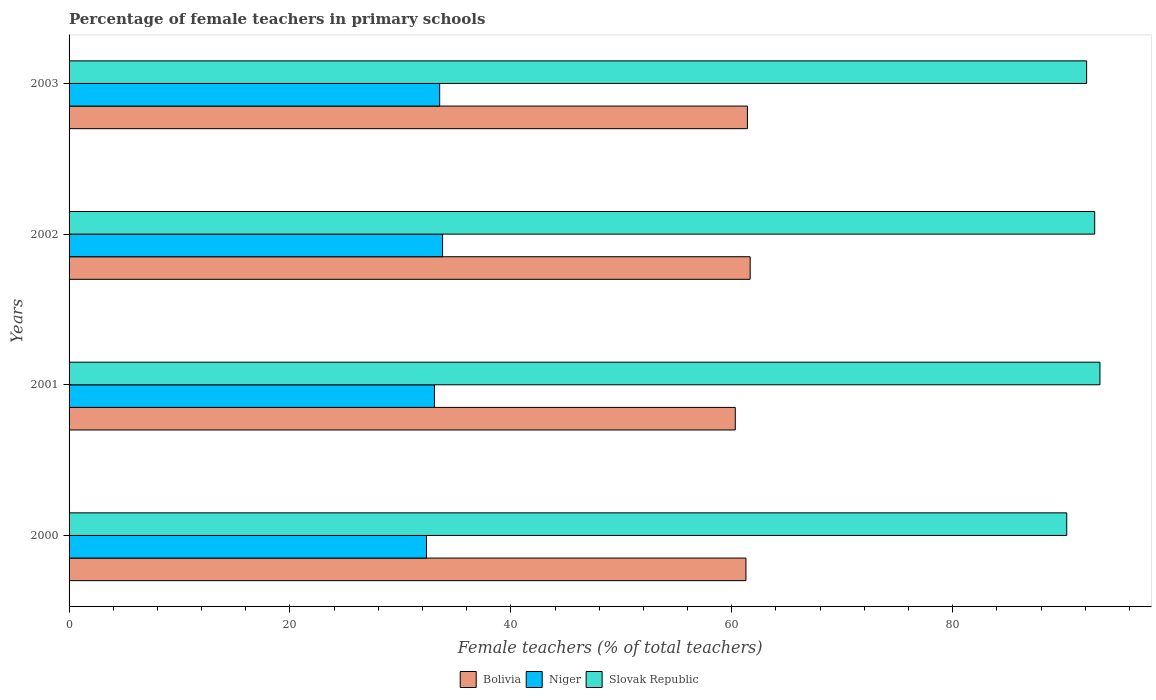How many groups of bars are there?
Offer a very short reply. 4. How many bars are there on the 3rd tick from the bottom?
Provide a short and direct response. 3. What is the label of the 4th group of bars from the top?
Offer a terse response. 2000. In how many cases, is the number of bars for a given year not equal to the number of legend labels?
Provide a succinct answer. 0. What is the percentage of female teachers in Bolivia in 2000?
Your answer should be compact. 61.28. Across all years, what is the maximum percentage of female teachers in Bolivia?
Offer a very short reply. 61.66. Across all years, what is the minimum percentage of female teachers in Niger?
Offer a very short reply. 32.36. In which year was the percentage of female teachers in Bolivia maximum?
Keep it short and to the point. 2002. In which year was the percentage of female teachers in Slovak Republic minimum?
Give a very brief answer. 2000. What is the total percentage of female teachers in Bolivia in the graph?
Offer a very short reply. 244.68. What is the difference between the percentage of female teachers in Slovak Republic in 2000 and that in 2003?
Offer a terse response. -1.8. What is the difference between the percentage of female teachers in Niger in 2000 and the percentage of female teachers in Bolivia in 2003?
Offer a terse response. -29.06. What is the average percentage of female teachers in Slovak Republic per year?
Keep it short and to the point. 92.16. In the year 2000, what is the difference between the percentage of female teachers in Bolivia and percentage of female teachers in Niger?
Make the answer very short. 28.92. What is the ratio of the percentage of female teachers in Niger in 2001 to that in 2002?
Provide a succinct answer. 0.98. Is the percentage of female teachers in Slovak Republic in 2001 less than that in 2002?
Your answer should be very brief. No. Is the difference between the percentage of female teachers in Bolivia in 2000 and 2002 greater than the difference between the percentage of female teachers in Niger in 2000 and 2002?
Your answer should be very brief. Yes. What is the difference between the highest and the second highest percentage of female teachers in Bolivia?
Provide a short and direct response. 0.25. What is the difference between the highest and the lowest percentage of female teachers in Niger?
Provide a succinct answer. 1.46. In how many years, is the percentage of female teachers in Slovak Republic greater than the average percentage of female teachers in Slovak Republic taken over all years?
Provide a succinct answer. 2. Is the sum of the percentage of female teachers in Slovak Republic in 2002 and 2003 greater than the maximum percentage of female teachers in Bolivia across all years?
Keep it short and to the point. Yes. What does the 1st bar from the top in 2001 represents?
Your answer should be very brief. Slovak Republic. What does the 1st bar from the bottom in 2000 represents?
Your response must be concise. Bolivia. Is it the case that in every year, the sum of the percentage of female teachers in Slovak Republic and percentage of female teachers in Niger is greater than the percentage of female teachers in Bolivia?
Your response must be concise. Yes. What is the difference between two consecutive major ticks on the X-axis?
Provide a succinct answer. 20. What is the title of the graph?
Provide a succinct answer. Percentage of female teachers in primary schools. Does "Chad" appear as one of the legend labels in the graph?
Provide a short and direct response. No. What is the label or title of the X-axis?
Ensure brevity in your answer.  Female teachers (% of total teachers). What is the Female teachers (% of total teachers) of Bolivia in 2000?
Provide a succinct answer. 61.28. What is the Female teachers (% of total teachers) in Niger in 2000?
Your answer should be very brief. 32.36. What is the Female teachers (% of total teachers) in Slovak Republic in 2000?
Offer a very short reply. 90.32. What is the Female teachers (% of total teachers) of Bolivia in 2001?
Provide a succinct answer. 60.32. What is the Female teachers (% of total teachers) of Niger in 2001?
Make the answer very short. 33.08. What is the Female teachers (% of total teachers) of Slovak Republic in 2001?
Ensure brevity in your answer.  93.33. What is the Female teachers (% of total teachers) of Bolivia in 2002?
Your answer should be very brief. 61.66. What is the Female teachers (% of total teachers) in Niger in 2002?
Offer a terse response. 33.82. What is the Female teachers (% of total teachers) in Slovak Republic in 2002?
Offer a very short reply. 92.85. What is the Female teachers (% of total teachers) of Bolivia in 2003?
Your answer should be compact. 61.42. What is the Female teachers (% of total teachers) of Niger in 2003?
Ensure brevity in your answer.  33.55. What is the Female teachers (% of total teachers) of Slovak Republic in 2003?
Your answer should be very brief. 92.13. Across all years, what is the maximum Female teachers (% of total teachers) in Bolivia?
Your response must be concise. 61.66. Across all years, what is the maximum Female teachers (% of total teachers) of Niger?
Make the answer very short. 33.82. Across all years, what is the maximum Female teachers (% of total teachers) of Slovak Republic?
Provide a succinct answer. 93.33. Across all years, what is the minimum Female teachers (% of total teachers) of Bolivia?
Your response must be concise. 60.32. Across all years, what is the minimum Female teachers (% of total teachers) in Niger?
Offer a terse response. 32.36. Across all years, what is the minimum Female teachers (% of total teachers) of Slovak Republic?
Your answer should be compact. 90.32. What is the total Female teachers (% of total teachers) in Bolivia in the graph?
Ensure brevity in your answer.  244.68. What is the total Female teachers (% of total teachers) in Niger in the graph?
Give a very brief answer. 132.81. What is the total Female teachers (% of total teachers) in Slovak Republic in the graph?
Ensure brevity in your answer.  368.64. What is the difference between the Female teachers (% of total teachers) of Bolivia in 2000 and that in 2001?
Offer a very short reply. 0.97. What is the difference between the Female teachers (% of total teachers) in Niger in 2000 and that in 2001?
Offer a terse response. -0.72. What is the difference between the Female teachers (% of total teachers) in Slovak Republic in 2000 and that in 2001?
Make the answer very short. -3.01. What is the difference between the Female teachers (% of total teachers) in Bolivia in 2000 and that in 2002?
Give a very brief answer. -0.38. What is the difference between the Female teachers (% of total teachers) of Niger in 2000 and that in 2002?
Your answer should be compact. -1.46. What is the difference between the Female teachers (% of total teachers) of Slovak Republic in 2000 and that in 2002?
Ensure brevity in your answer.  -2.53. What is the difference between the Female teachers (% of total teachers) in Bolivia in 2000 and that in 2003?
Ensure brevity in your answer.  -0.13. What is the difference between the Female teachers (% of total teachers) in Niger in 2000 and that in 2003?
Your answer should be very brief. -1.19. What is the difference between the Female teachers (% of total teachers) in Slovak Republic in 2000 and that in 2003?
Offer a very short reply. -1.8. What is the difference between the Female teachers (% of total teachers) in Bolivia in 2001 and that in 2002?
Give a very brief answer. -1.35. What is the difference between the Female teachers (% of total teachers) in Niger in 2001 and that in 2002?
Your answer should be compact. -0.74. What is the difference between the Female teachers (% of total teachers) in Slovak Republic in 2001 and that in 2002?
Ensure brevity in your answer.  0.48. What is the difference between the Female teachers (% of total teachers) in Bolivia in 2001 and that in 2003?
Offer a very short reply. -1.1. What is the difference between the Female teachers (% of total teachers) in Niger in 2001 and that in 2003?
Your answer should be very brief. -0.47. What is the difference between the Female teachers (% of total teachers) of Slovak Republic in 2001 and that in 2003?
Ensure brevity in your answer.  1.21. What is the difference between the Female teachers (% of total teachers) of Bolivia in 2002 and that in 2003?
Your answer should be compact. 0.25. What is the difference between the Female teachers (% of total teachers) in Niger in 2002 and that in 2003?
Offer a very short reply. 0.26. What is the difference between the Female teachers (% of total teachers) of Slovak Republic in 2002 and that in 2003?
Give a very brief answer. 0.73. What is the difference between the Female teachers (% of total teachers) in Bolivia in 2000 and the Female teachers (% of total teachers) in Niger in 2001?
Your answer should be compact. 28.2. What is the difference between the Female teachers (% of total teachers) in Bolivia in 2000 and the Female teachers (% of total teachers) in Slovak Republic in 2001?
Your answer should be compact. -32.05. What is the difference between the Female teachers (% of total teachers) in Niger in 2000 and the Female teachers (% of total teachers) in Slovak Republic in 2001?
Your answer should be very brief. -60.97. What is the difference between the Female teachers (% of total teachers) of Bolivia in 2000 and the Female teachers (% of total teachers) of Niger in 2002?
Offer a terse response. 27.47. What is the difference between the Female teachers (% of total teachers) in Bolivia in 2000 and the Female teachers (% of total teachers) in Slovak Republic in 2002?
Ensure brevity in your answer.  -31.57. What is the difference between the Female teachers (% of total teachers) of Niger in 2000 and the Female teachers (% of total teachers) of Slovak Republic in 2002?
Your answer should be very brief. -60.49. What is the difference between the Female teachers (% of total teachers) in Bolivia in 2000 and the Female teachers (% of total teachers) in Niger in 2003?
Provide a short and direct response. 27.73. What is the difference between the Female teachers (% of total teachers) in Bolivia in 2000 and the Female teachers (% of total teachers) in Slovak Republic in 2003?
Provide a succinct answer. -30.84. What is the difference between the Female teachers (% of total teachers) of Niger in 2000 and the Female teachers (% of total teachers) of Slovak Republic in 2003?
Offer a terse response. -59.77. What is the difference between the Female teachers (% of total teachers) in Bolivia in 2001 and the Female teachers (% of total teachers) in Niger in 2002?
Your answer should be very brief. 26.5. What is the difference between the Female teachers (% of total teachers) in Bolivia in 2001 and the Female teachers (% of total teachers) in Slovak Republic in 2002?
Offer a very short reply. -32.54. What is the difference between the Female teachers (% of total teachers) in Niger in 2001 and the Female teachers (% of total teachers) in Slovak Republic in 2002?
Provide a succinct answer. -59.77. What is the difference between the Female teachers (% of total teachers) in Bolivia in 2001 and the Female teachers (% of total teachers) in Niger in 2003?
Your response must be concise. 26.76. What is the difference between the Female teachers (% of total teachers) of Bolivia in 2001 and the Female teachers (% of total teachers) of Slovak Republic in 2003?
Your answer should be very brief. -31.81. What is the difference between the Female teachers (% of total teachers) of Niger in 2001 and the Female teachers (% of total teachers) of Slovak Republic in 2003?
Provide a short and direct response. -59.05. What is the difference between the Female teachers (% of total teachers) in Bolivia in 2002 and the Female teachers (% of total teachers) in Niger in 2003?
Your answer should be very brief. 28.11. What is the difference between the Female teachers (% of total teachers) in Bolivia in 2002 and the Female teachers (% of total teachers) in Slovak Republic in 2003?
Your answer should be very brief. -30.46. What is the difference between the Female teachers (% of total teachers) of Niger in 2002 and the Female teachers (% of total teachers) of Slovak Republic in 2003?
Offer a terse response. -58.31. What is the average Female teachers (% of total teachers) of Bolivia per year?
Provide a succinct answer. 61.17. What is the average Female teachers (% of total teachers) of Niger per year?
Your answer should be very brief. 33.2. What is the average Female teachers (% of total teachers) of Slovak Republic per year?
Your response must be concise. 92.16. In the year 2000, what is the difference between the Female teachers (% of total teachers) in Bolivia and Female teachers (% of total teachers) in Niger?
Keep it short and to the point. 28.92. In the year 2000, what is the difference between the Female teachers (% of total teachers) of Bolivia and Female teachers (% of total teachers) of Slovak Republic?
Your answer should be very brief. -29.04. In the year 2000, what is the difference between the Female teachers (% of total teachers) in Niger and Female teachers (% of total teachers) in Slovak Republic?
Make the answer very short. -57.96. In the year 2001, what is the difference between the Female teachers (% of total teachers) in Bolivia and Female teachers (% of total teachers) in Niger?
Offer a very short reply. 27.24. In the year 2001, what is the difference between the Female teachers (% of total teachers) in Bolivia and Female teachers (% of total teachers) in Slovak Republic?
Your answer should be very brief. -33.02. In the year 2001, what is the difference between the Female teachers (% of total teachers) in Niger and Female teachers (% of total teachers) in Slovak Republic?
Offer a very short reply. -60.25. In the year 2002, what is the difference between the Female teachers (% of total teachers) in Bolivia and Female teachers (% of total teachers) in Niger?
Make the answer very short. 27.85. In the year 2002, what is the difference between the Female teachers (% of total teachers) of Bolivia and Female teachers (% of total teachers) of Slovak Republic?
Your answer should be very brief. -31.19. In the year 2002, what is the difference between the Female teachers (% of total teachers) of Niger and Female teachers (% of total teachers) of Slovak Republic?
Your response must be concise. -59.04. In the year 2003, what is the difference between the Female teachers (% of total teachers) in Bolivia and Female teachers (% of total teachers) in Niger?
Your response must be concise. 27.86. In the year 2003, what is the difference between the Female teachers (% of total teachers) of Bolivia and Female teachers (% of total teachers) of Slovak Republic?
Ensure brevity in your answer.  -30.71. In the year 2003, what is the difference between the Female teachers (% of total teachers) in Niger and Female teachers (% of total teachers) in Slovak Republic?
Your answer should be compact. -58.57. What is the ratio of the Female teachers (% of total teachers) of Bolivia in 2000 to that in 2001?
Ensure brevity in your answer.  1.02. What is the ratio of the Female teachers (% of total teachers) in Niger in 2000 to that in 2001?
Your response must be concise. 0.98. What is the ratio of the Female teachers (% of total teachers) of Slovak Republic in 2000 to that in 2001?
Ensure brevity in your answer.  0.97. What is the ratio of the Female teachers (% of total teachers) in Niger in 2000 to that in 2002?
Offer a terse response. 0.96. What is the ratio of the Female teachers (% of total teachers) in Slovak Republic in 2000 to that in 2002?
Keep it short and to the point. 0.97. What is the ratio of the Female teachers (% of total teachers) of Bolivia in 2000 to that in 2003?
Make the answer very short. 1. What is the ratio of the Female teachers (% of total teachers) in Niger in 2000 to that in 2003?
Provide a succinct answer. 0.96. What is the ratio of the Female teachers (% of total teachers) of Slovak Republic in 2000 to that in 2003?
Your answer should be very brief. 0.98. What is the ratio of the Female teachers (% of total teachers) of Bolivia in 2001 to that in 2002?
Ensure brevity in your answer.  0.98. What is the ratio of the Female teachers (% of total teachers) in Niger in 2001 to that in 2002?
Offer a very short reply. 0.98. What is the ratio of the Female teachers (% of total teachers) of Slovak Republic in 2001 to that in 2002?
Offer a very short reply. 1.01. What is the ratio of the Female teachers (% of total teachers) of Bolivia in 2001 to that in 2003?
Ensure brevity in your answer.  0.98. What is the ratio of the Female teachers (% of total teachers) in Niger in 2001 to that in 2003?
Offer a very short reply. 0.99. What is the ratio of the Female teachers (% of total teachers) of Slovak Republic in 2001 to that in 2003?
Provide a short and direct response. 1.01. What is the ratio of the Female teachers (% of total teachers) of Niger in 2002 to that in 2003?
Provide a succinct answer. 1.01. What is the ratio of the Female teachers (% of total teachers) of Slovak Republic in 2002 to that in 2003?
Keep it short and to the point. 1.01. What is the difference between the highest and the second highest Female teachers (% of total teachers) in Bolivia?
Offer a very short reply. 0.25. What is the difference between the highest and the second highest Female teachers (% of total teachers) in Niger?
Ensure brevity in your answer.  0.26. What is the difference between the highest and the second highest Female teachers (% of total teachers) of Slovak Republic?
Provide a short and direct response. 0.48. What is the difference between the highest and the lowest Female teachers (% of total teachers) of Bolivia?
Your response must be concise. 1.35. What is the difference between the highest and the lowest Female teachers (% of total teachers) in Niger?
Keep it short and to the point. 1.46. What is the difference between the highest and the lowest Female teachers (% of total teachers) of Slovak Republic?
Keep it short and to the point. 3.01. 